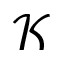<formula> <loc_0><loc_0><loc_500><loc_500>\mathcal { K }</formula> 